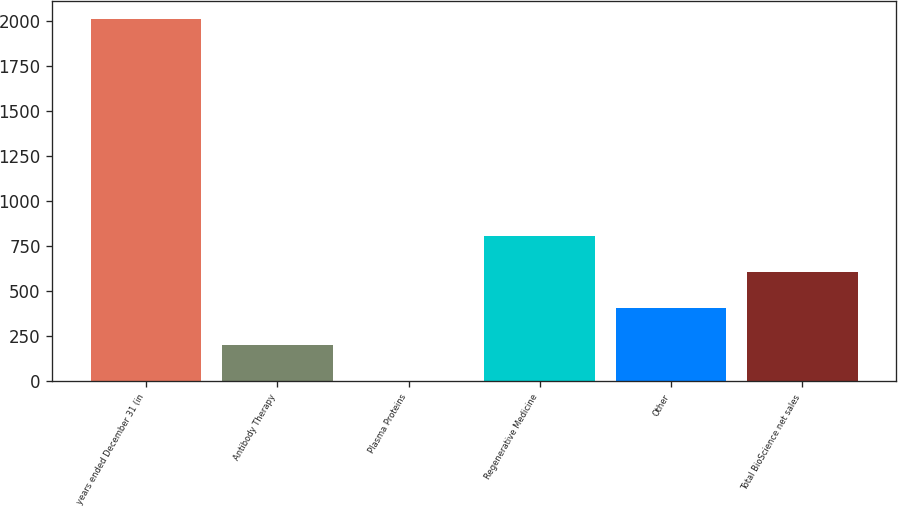Convert chart. <chart><loc_0><loc_0><loc_500><loc_500><bar_chart><fcel>years ended December 31 (in<fcel>Antibody Therapy<fcel>Plasma Proteins<fcel>Regenerative Medicine<fcel>Other<fcel>Total BioScience net sales<nl><fcel>2012<fcel>203<fcel>2<fcel>806<fcel>404<fcel>605<nl></chart> 